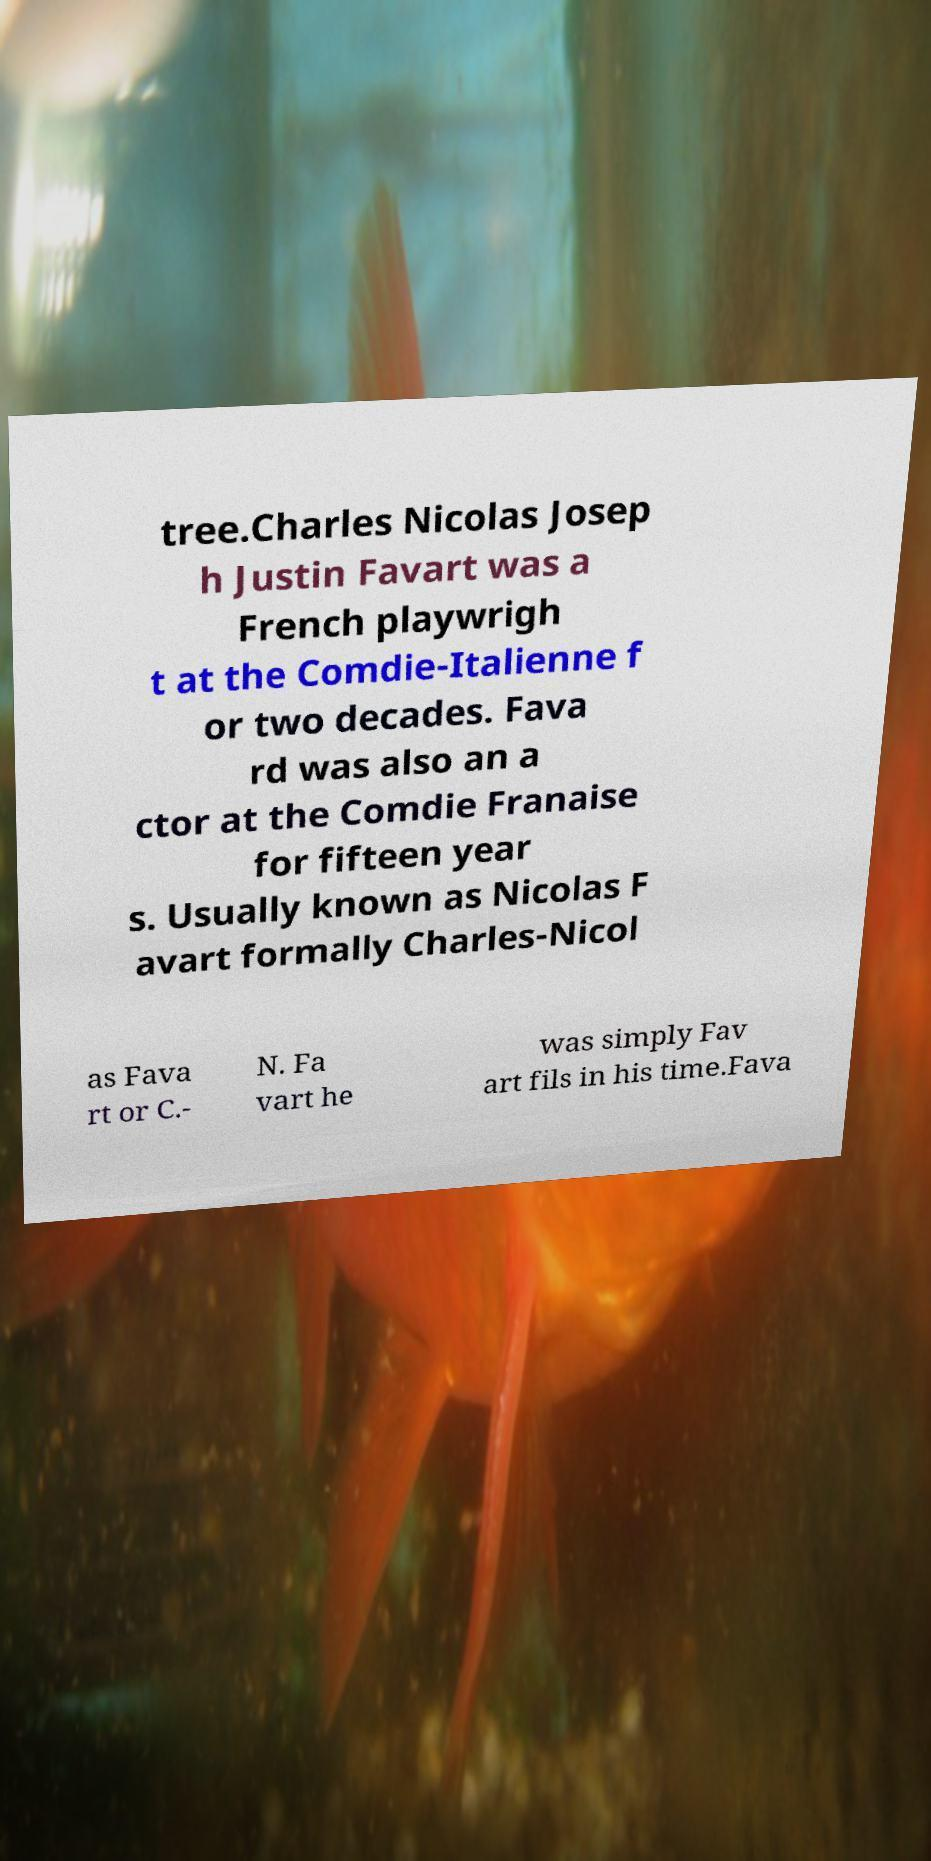Please identify and transcribe the text found in this image. tree.Charles Nicolas Josep h Justin Favart was a French playwrigh t at the Comdie-Italienne f or two decades. Fava rd was also an a ctor at the Comdie Franaise for fifteen year s. Usually known as Nicolas F avart formally Charles-Nicol as Fava rt or C.- N. Fa vart he was simply Fav art fils in his time.Fava 